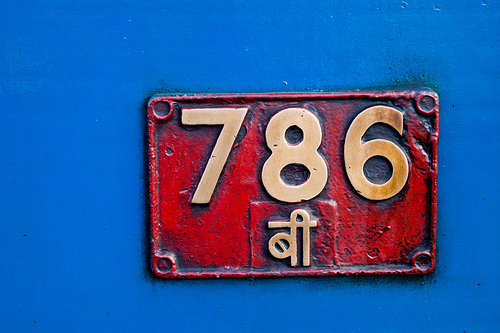<image>
Is there a six next to the seven? No. The six is not positioned next to the seven. They are located in different areas of the scene. 